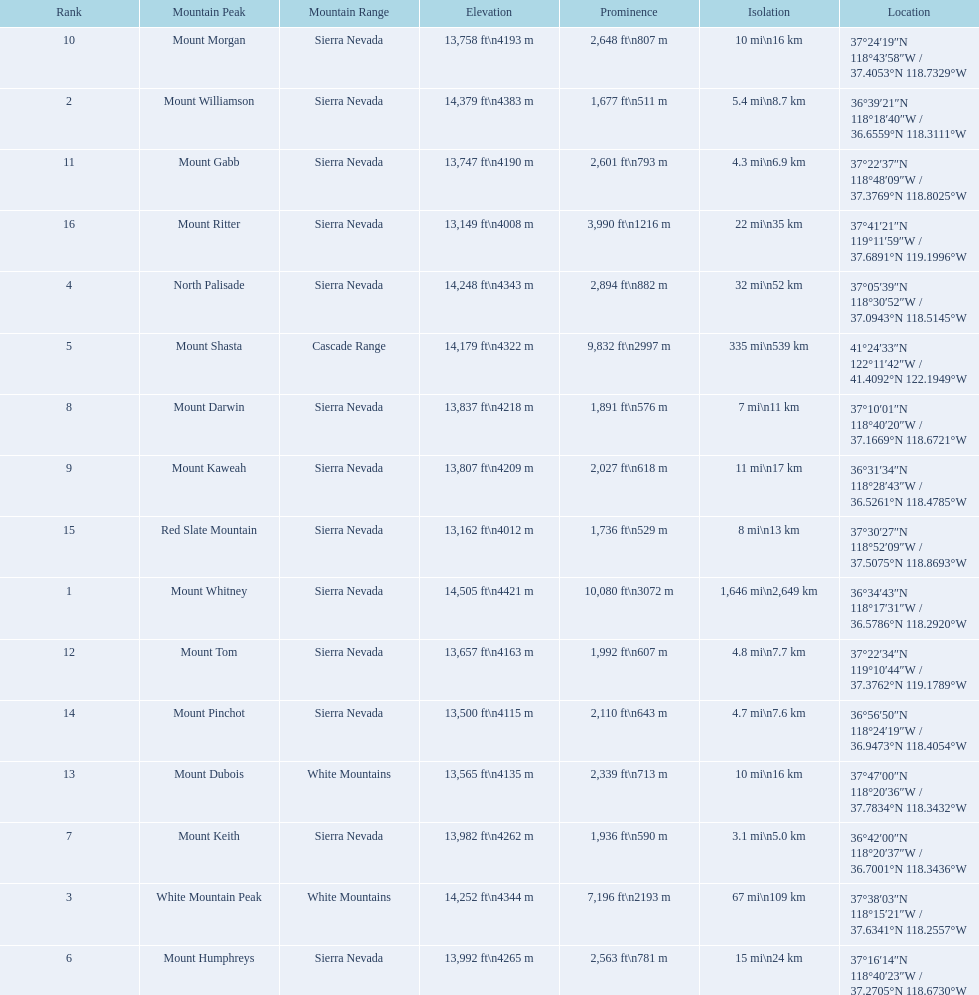Which mountain peak has a prominence more than 10,000 ft? Mount Whitney. 